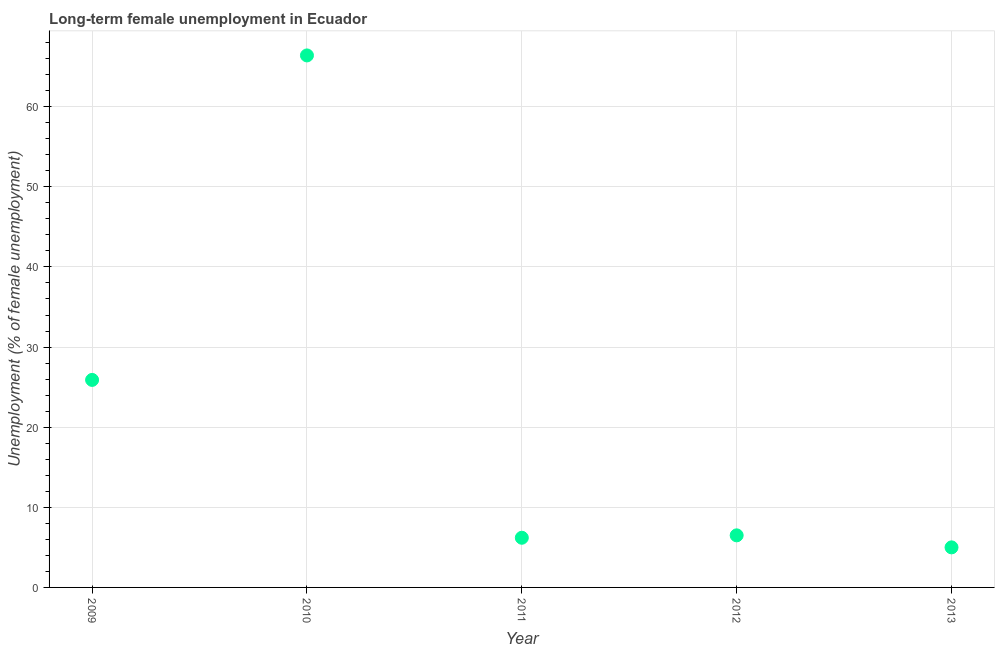What is the long-term female unemployment in 2011?
Your answer should be compact. 6.2. Across all years, what is the maximum long-term female unemployment?
Provide a short and direct response. 66.4. In which year was the long-term female unemployment maximum?
Provide a short and direct response. 2010. In which year was the long-term female unemployment minimum?
Your response must be concise. 2013. What is the sum of the long-term female unemployment?
Offer a very short reply. 110. What is the average long-term female unemployment per year?
Your answer should be very brief. 22. What is the ratio of the long-term female unemployment in 2010 to that in 2011?
Offer a terse response. 10.71. Is the long-term female unemployment in 2012 less than that in 2013?
Your answer should be very brief. No. Is the difference between the long-term female unemployment in 2012 and 2013 greater than the difference between any two years?
Your answer should be compact. No. What is the difference between the highest and the second highest long-term female unemployment?
Give a very brief answer. 40.5. Is the sum of the long-term female unemployment in 2010 and 2013 greater than the maximum long-term female unemployment across all years?
Provide a succinct answer. Yes. What is the difference between the highest and the lowest long-term female unemployment?
Offer a terse response. 61.4. Does the long-term female unemployment monotonically increase over the years?
Offer a terse response. No. Are the values on the major ticks of Y-axis written in scientific E-notation?
Keep it short and to the point. No. Does the graph contain any zero values?
Provide a short and direct response. No. Does the graph contain grids?
Make the answer very short. Yes. What is the title of the graph?
Your answer should be compact. Long-term female unemployment in Ecuador. What is the label or title of the Y-axis?
Your response must be concise. Unemployment (% of female unemployment). What is the Unemployment (% of female unemployment) in 2009?
Give a very brief answer. 25.9. What is the Unemployment (% of female unemployment) in 2010?
Your answer should be compact. 66.4. What is the Unemployment (% of female unemployment) in 2011?
Make the answer very short. 6.2. What is the Unemployment (% of female unemployment) in 2012?
Your answer should be very brief. 6.5. What is the Unemployment (% of female unemployment) in 2013?
Offer a terse response. 5. What is the difference between the Unemployment (% of female unemployment) in 2009 and 2010?
Your answer should be very brief. -40.5. What is the difference between the Unemployment (% of female unemployment) in 2009 and 2011?
Ensure brevity in your answer.  19.7. What is the difference between the Unemployment (% of female unemployment) in 2009 and 2012?
Your response must be concise. 19.4. What is the difference between the Unemployment (% of female unemployment) in 2009 and 2013?
Offer a terse response. 20.9. What is the difference between the Unemployment (% of female unemployment) in 2010 and 2011?
Keep it short and to the point. 60.2. What is the difference between the Unemployment (% of female unemployment) in 2010 and 2012?
Keep it short and to the point. 59.9. What is the difference between the Unemployment (% of female unemployment) in 2010 and 2013?
Give a very brief answer. 61.4. What is the difference between the Unemployment (% of female unemployment) in 2011 and 2013?
Your answer should be very brief. 1.2. What is the ratio of the Unemployment (% of female unemployment) in 2009 to that in 2010?
Your response must be concise. 0.39. What is the ratio of the Unemployment (% of female unemployment) in 2009 to that in 2011?
Provide a succinct answer. 4.18. What is the ratio of the Unemployment (% of female unemployment) in 2009 to that in 2012?
Make the answer very short. 3.98. What is the ratio of the Unemployment (% of female unemployment) in 2009 to that in 2013?
Your answer should be compact. 5.18. What is the ratio of the Unemployment (% of female unemployment) in 2010 to that in 2011?
Ensure brevity in your answer.  10.71. What is the ratio of the Unemployment (% of female unemployment) in 2010 to that in 2012?
Offer a very short reply. 10.21. What is the ratio of the Unemployment (% of female unemployment) in 2010 to that in 2013?
Make the answer very short. 13.28. What is the ratio of the Unemployment (% of female unemployment) in 2011 to that in 2012?
Ensure brevity in your answer.  0.95. What is the ratio of the Unemployment (% of female unemployment) in 2011 to that in 2013?
Provide a short and direct response. 1.24. 